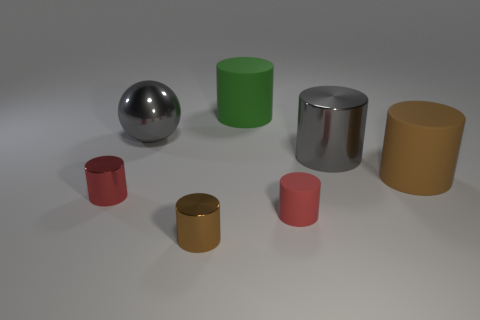Subtract all green cylinders. How many cylinders are left? 5 Subtract all big green rubber cylinders. How many cylinders are left? 5 Subtract all blue cylinders. Subtract all red blocks. How many cylinders are left? 6 Add 1 big green matte balls. How many objects exist? 8 Subtract all spheres. How many objects are left? 6 Subtract all tiny red shiny objects. Subtract all green matte objects. How many objects are left? 5 Add 5 large gray metal things. How many large gray metal things are left? 7 Add 5 large shiny cylinders. How many large shiny cylinders exist? 6 Subtract 0 blue blocks. How many objects are left? 7 